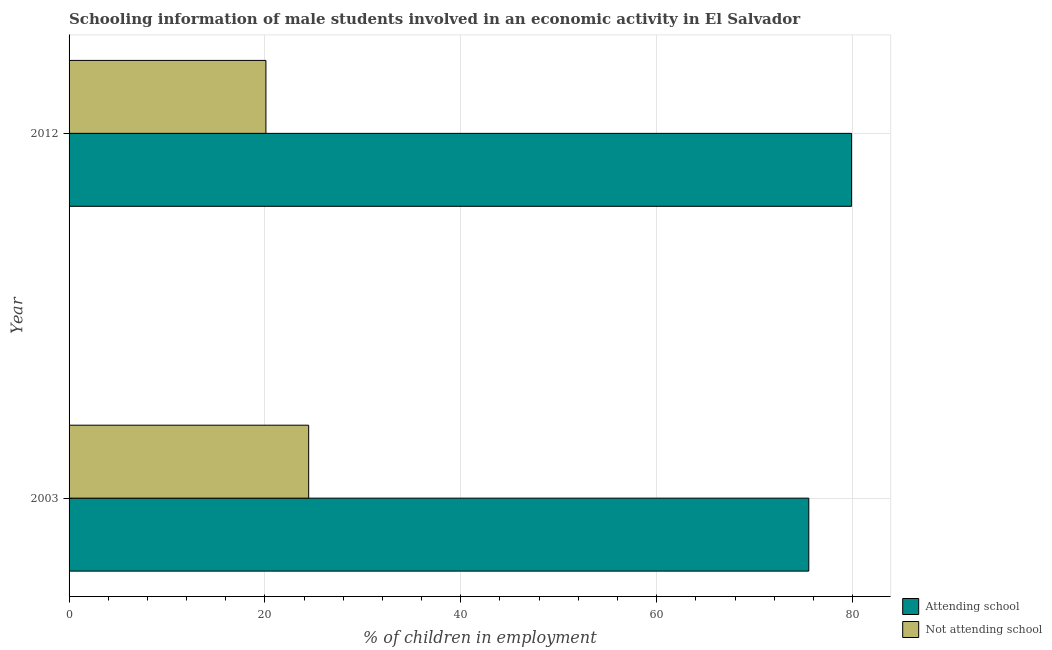How many groups of bars are there?
Offer a very short reply. 2. How many bars are there on the 1st tick from the bottom?
Your answer should be very brief. 2. In how many cases, is the number of bars for a given year not equal to the number of legend labels?
Keep it short and to the point. 0. What is the percentage of employed males who are not attending school in 2003?
Your answer should be compact. 24.47. Across all years, what is the maximum percentage of employed males who are not attending school?
Ensure brevity in your answer.  24.47. Across all years, what is the minimum percentage of employed males who are attending school?
Give a very brief answer. 75.53. In which year was the percentage of employed males who are not attending school minimum?
Your answer should be very brief. 2012. What is the total percentage of employed males who are not attending school in the graph?
Make the answer very short. 44.57. What is the difference between the percentage of employed males who are not attending school in 2003 and that in 2012?
Your answer should be compact. 4.37. What is the difference between the percentage of employed males who are attending school in 2003 and the percentage of employed males who are not attending school in 2012?
Provide a succinct answer. 55.43. What is the average percentage of employed males who are not attending school per year?
Make the answer very short. 22.28. In the year 2003, what is the difference between the percentage of employed males who are not attending school and percentage of employed males who are attending school?
Your response must be concise. -51.07. What is the ratio of the percentage of employed males who are attending school in 2003 to that in 2012?
Ensure brevity in your answer.  0.94. Is the percentage of employed males who are not attending school in 2003 less than that in 2012?
Your answer should be very brief. No. What does the 1st bar from the top in 2003 represents?
Offer a terse response. Not attending school. What does the 2nd bar from the bottom in 2003 represents?
Your answer should be compact. Not attending school. Are all the bars in the graph horizontal?
Your answer should be very brief. Yes. What is the difference between two consecutive major ticks on the X-axis?
Your answer should be very brief. 20. Does the graph contain any zero values?
Your answer should be compact. No. Where does the legend appear in the graph?
Make the answer very short. Bottom right. What is the title of the graph?
Your answer should be very brief. Schooling information of male students involved in an economic activity in El Salvador. Does "Short-term debt" appear as one of the legend labels in the graph?
Provide a short and direct response. No. What is the label or title of the X-axis?
Your answer should be compact. % of children in employment. What is the % of children in employment of Attending school in 2003?
Your answer should be compact. 75.53. What is the % of children in employment in Not attending school in 2003?
Keep it short and to the point. 24.47. What is the % of children in employment of Attending school in 2012?
Keep it short and to the point. 79.9. What is the % of children in employment of Not attending school in 2012?
Offer a very short reply. 20.1. Across all years, what is the maximum % of children in employment in Attending school?
Keep it short and to the point. 79.9. Across all years, what is the maximum % of children in employment in Not attending school?
Provide a short and direct response. 24.47. Across all years, what is the minimum % of children in employment of Attending school?
Make the answer very short. 75.53. Across all years, what is the minimum % of children in employment in Not attending school?
Your answer should be very brief. 20.1. What is the total % of children in employment in Attending school in the graph?
Your answer should be compact. 155.43. What is the total % of children in employment in Not attending school in the graph?
Keep it short and to the point. 44.57. What is the difference between the % of children in employment of Attending school in 2003 and that in 2012?
Your response must be concise. -4.37. What is the difference between the % of children in employment of Not attending school in 2003 and that in 2012?
Ensure brevity in your answer.  4.37. What is the difference between the % of children in employment of Attending school in 2003 and the % of children in employment of Not attending school in 2012?
Your answer should be very brief. 55.43. What is the average % of children in employment of Attending school per year?
Make the answer very short. 77.72. What is the average % of children in employment in Not attending school per year?
Your response must be concise. 22.28. In the year 2003, what is the difference between the % of children in employment of Attending school and % of children in employment of Not attending school?
Offer a very short reply. 51.07. In the year 2012, what is the difference between the % of children in employment in Attending school and % of children in employment in Not attending school?
Provide a short and direct response. 59.8. What is the ratio of the % of children in employment in Attending school in 2003 to that in 2012?
Your answer should be very brief. 0.95. What is the ratio of the % of children in employment of Not attending school in 2003 to that in 2012?
Provide a succinct answer. 1.22. What is the difference between the highest and the second highest % of children in employment of Attending school?
Your response must be concise. 4.37. What is the difference between the highest and the second highest % of children in employment in Not attending school?
Keep it short and to the point. 4.37. What is the difference between the highest and the lowest % of children in employment of Attending school?
Keep it short and to the point. 4.37. What is the difference between the highest and the lowest % of children in employment in Not attending school?
Give a very brief answer. 4.37. 